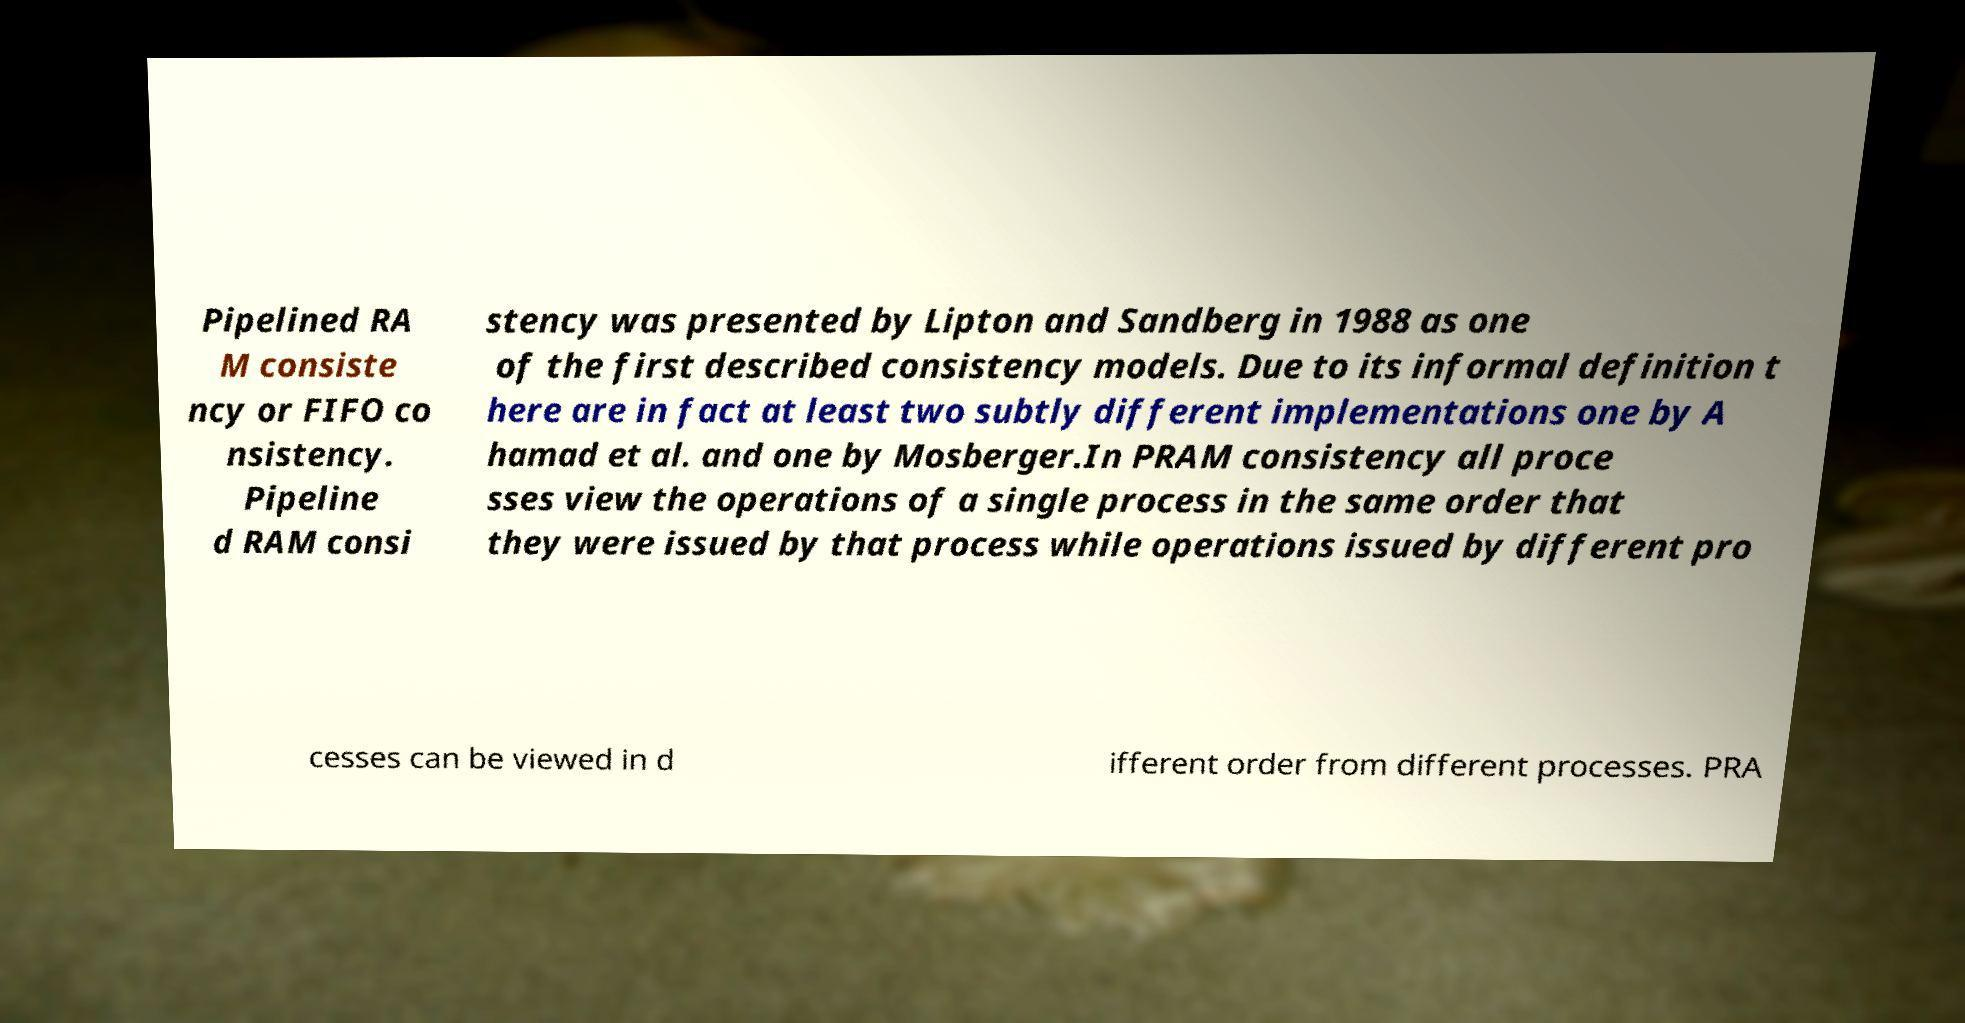There's text embedded in this image that I need extracted. Can you transcribe it verbatim? Pipelined RA M consiste ncy or FIFO co nsistency. Pipeline d RAM consi stency was presented by Lipton and Sandberg in 1988 as one of the first described consistency models. Due to its informal definition t here are in fact at least two subtly different implementations one by A hamad et al. and one by Mosberger.In PRAM consistency all proce sses view the operations of a single process in the same order that they were issued by that process while operations issued by different pro cesses can be viewed in d ifferent order from different processes. PRA 